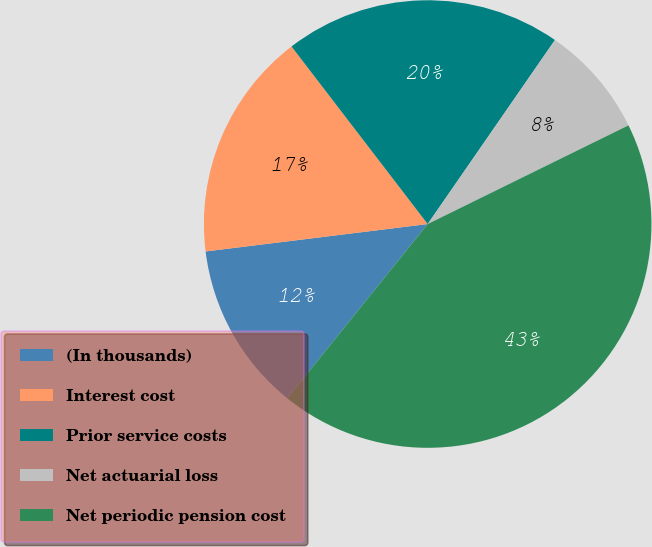<chart> <loc_0><loc_0><loc_500><loc_500><pie_chart><fcel>(In thousands)<fcel>Interest cost<fcel>Prior service costs<fcel>Net actuarial loss<fcel>Net periodic pension cost<nl><fcel>12.25%<fcel>16.54%<fcel>20.04%<fcel>8.1%<fcel>43.06%<nl></chart> 